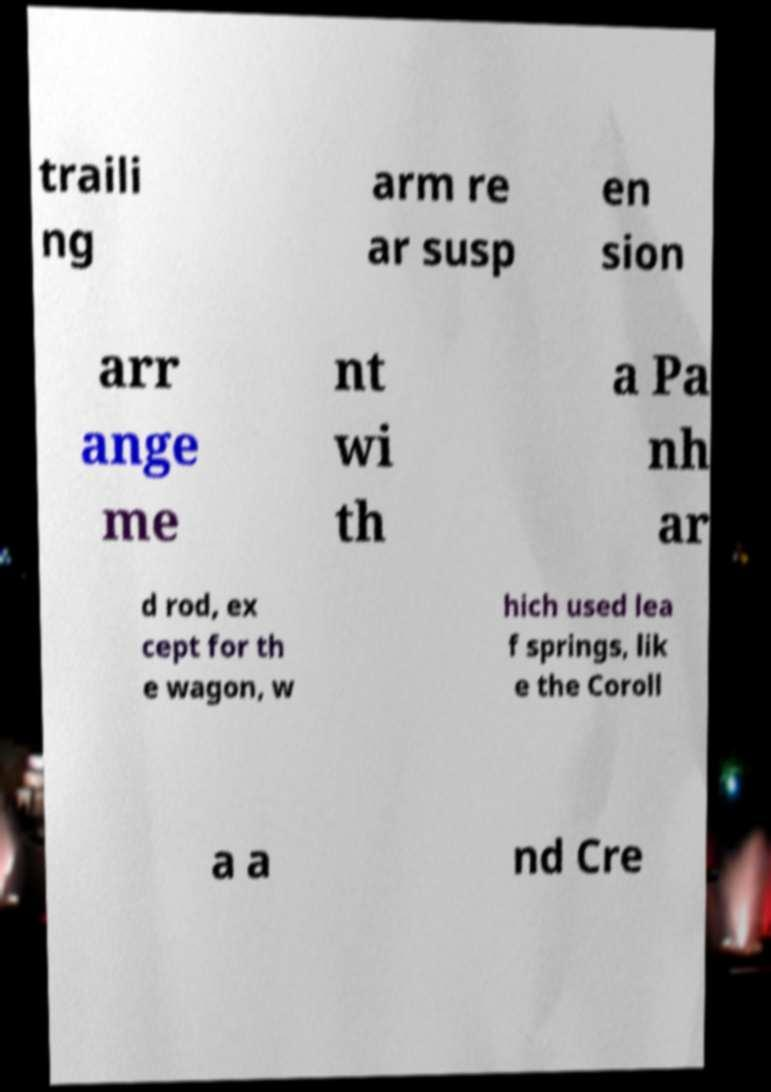Please read and relay the text visible in this image. What does it say? traili ng arm re ar susp en sion arr ange me nt wi th a Pa nh ar d rod, ex cept for th e wagon, w hich used lea f springs, lik e the Coroll a a nd Cre 